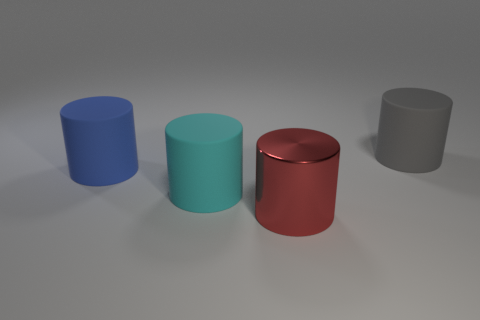There is a big cylinder that is both to the right of the large cyan cylinder and in front of the large blue object; what material is it?
Provide a succinct answer. Metal. Is the number of big red things behind the cyan matte cylinder less than the number of cylinders in front of the gray rubber thing?
Your response must be concise. Yes. Is the gray cylinder made of the same material as the red object on the right side of the big blue matte object?
Your answer should be compact. No. What is the material of the large red object that is the same shape as the large cyan rubber thing?
Your answer should be compact. Metal. Is there anything else that has the same material as the red cylinder?
Make the answer very short. No. Is the material of the cylinder that is on the right side of the red metallic cylinder the same as the object in front of the cyan object?
Provide a short and direct response. No. What color is the rubber object in front of the rubber object that is to the left of the matte cylinder in front of the blue rubber cylinder?
Offer a terse response. Cyan. How many other things are there of the same shape as the gray object?
Offer a very short reply. 3. What number of objects are either small red rubber cylinders or big red objects that are to the right of the big cyan rubber object?
Ensure brevity in your answer.  1. Is there a gray sphere of the same size as the metallic cylinder?
Your answer should be compact. No. 